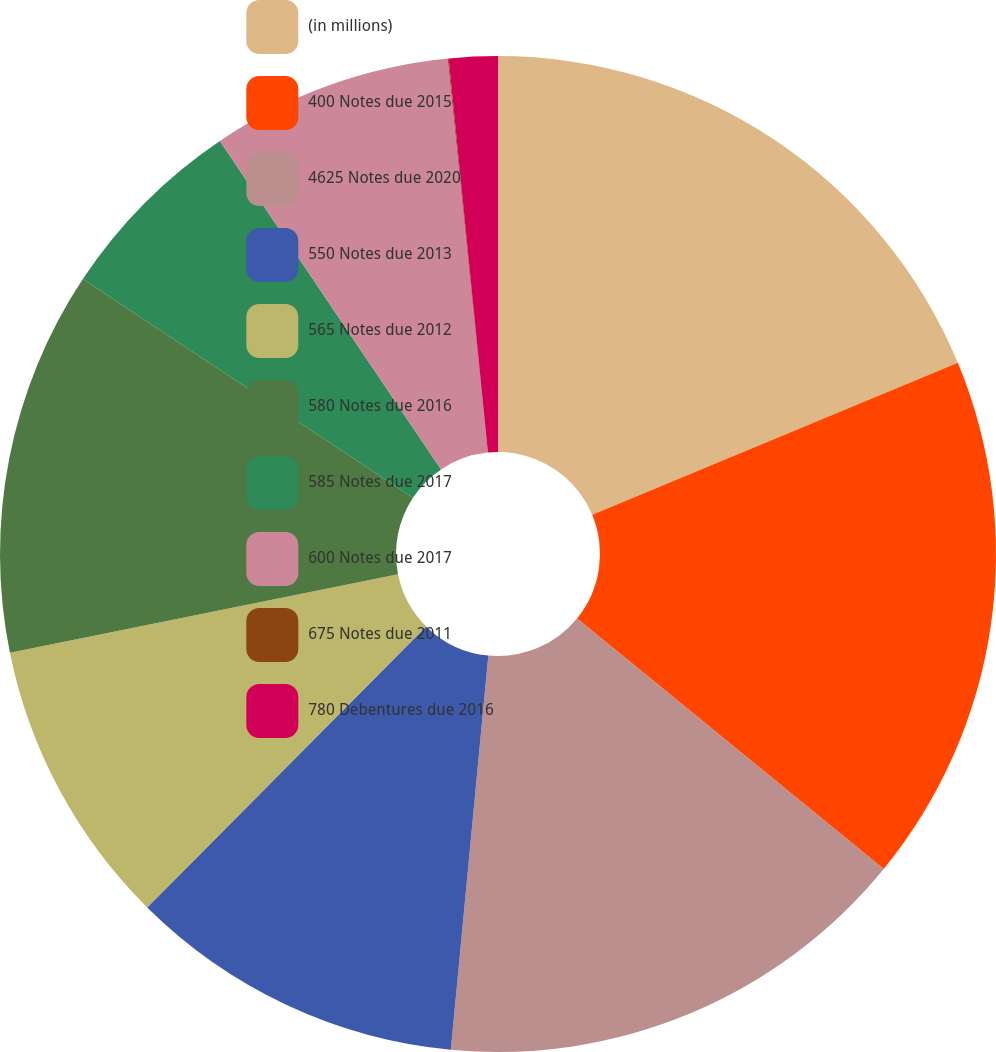<chart> <loc_0><loc_0><loc_500><loc_500><pie_chart><fcel>(in millions)<fcel>400 Notes due 2015<fcel>4625 Notes due 2020<fcel>550 Notes due 2013<fcel>565 Notes due 2012<fcel>580 Notes due 2016<fcel>585 Notes due 2017<fcel>600 Notes due 2017<fcel>675 Notes due 2011<fcel>780 Debentures due 2016<nl><fcel>18.73%<fcel>17.17%<fcel>15.61%<fcel>10.93%<fcel>9.38%<fcel>12.49%<fcel>6.26%<fcel>7.82%<fcel>0.03%<fcel>1.58%<nl></chart> 